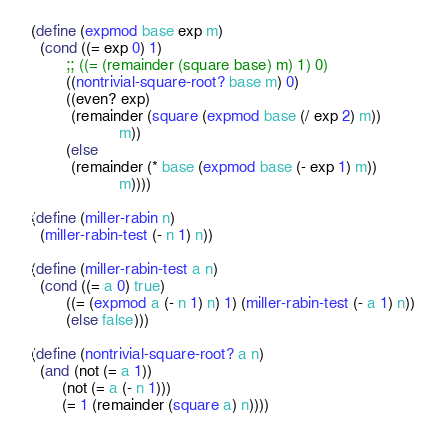<code> <loc_0><loc_0><loc_500><loc_500><_Scheme_>(define (expmod base exp m)
  (cond ((= exp 0) 1)
        ;; ((= (remainder (square base) m) 1) 0)
        ((nontrivial-square-root? base m) 0)
        ((even? exp)
         (remainder (square (expmod base (/ exp 2) m))
                    m))
        (else
         (remainder (* base (expmod base (- exp 1) m))
                    m))))

(define (miller-rabin n)
  (miller-rabin-test (- n 1) n))

(define (miller-rabin-test a n)
  (cond ((= a 0) true)
        ((= (expmod a (- n 1) n) 1) (miller-rabin-test (- a 1) n))
        (else false)))

(define (nontrivial-square-root? a n)
  (and (not (= a 1))
       (not (= a (- n 1)))
       (= 1 (remainder (square a) n))))
</code> 